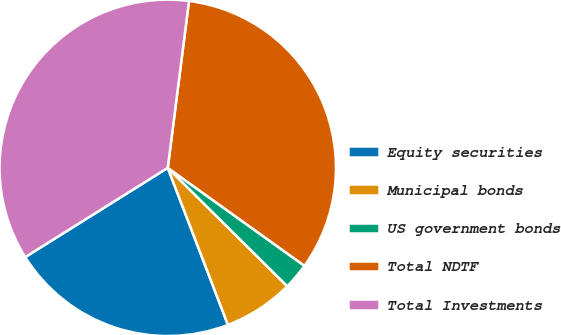<chart> <loc_0><loc_0><loc_500><loc_500><pie_chart><fcel>Equity securities<fcel>Municipal bonds<fcel>US government bonds<fcel>Total NDTF<fcel>Total Investments<nl><fcel>21.92%<fcel>6.75%<fcel>2.53%<fcel>32.88%<fcel>35.92%<nl></chart> 